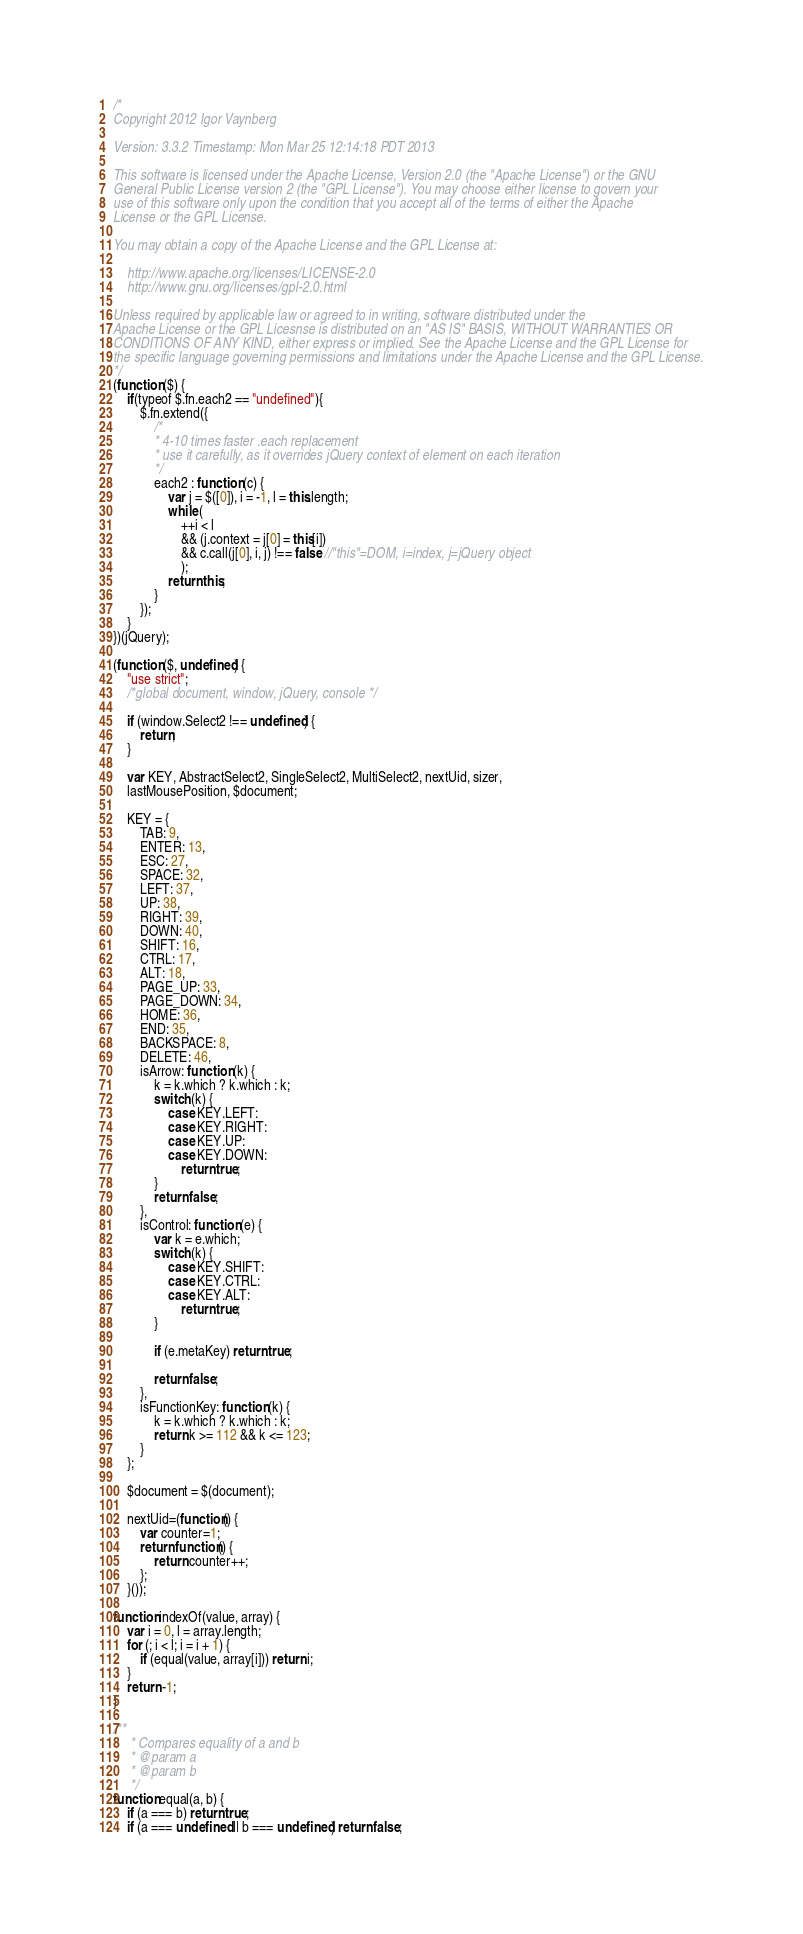Convert code to text. <code><loc_0><loc_0><loc_500><loc_500><_JavaScript_>/*
Copyright 2012 Igor Vaynberg

Version: 3.3.2 Timestamp: Mon Mar 25 12:14:18 PDT 2013

This software is licensed under the Apache License, Version 2.0 (the "Apache License") or the GNU
General Public License version 2 (the "GPL License"). You may choose either license to govern your
use of this software only upon the condition that you accept all of the terms of either the Apache
License or the GPL License.

You may obtain a copy of the Apache License and the GPL License at:

    http://www.apache.org/licenses/LICENSE-2.0
    http://www.gnu.org/licenses/gpl-2.0.html

Unless required by applicable law or agreed to in writing, software distributed under the
Apache License or the GPL Licesnse is distributed on an "AS IS" BASIS, WITHOUT WARRANTIES OR
CONDITIONS OF ANY KIND, either express or implied. See the Apache License and the GPL License for
the specific language governing permissions and limitations under the Apache License and the GPL License.
*/
(function ($) {
    if(typeof $.fn.each2 == "undefined"){
        $.fn.extend({
            /*
			* 4-10 times faster .each replacement
			* use it carefully, as it overrides jQuery context of element on each iteration
			*/
            each2 : function (c) {
                var j = $([0]), i = -1, l = this.length;
                while (
                    ++i < l
                    && (j.context = j[0] = this[i])
                    && c.call(j[0], i, j) !== false //"this"=DOM, i=index, j=jQuery object
                    );
                return this;
            }
        });
    }
})(jQuery);

(function ($, undefined) {
    "use strict";
    /*global document, window, jQuery, console */

    if (window.Select2 !== undefined) {
        return;
    }

    var KEY, AbstractSelect2, SingleSelect2, MultiSelect2, nextUid, sizer,
    lastMousePosition, $document;

    KEY = {
        TAB: 9,
        ENTER: 13,
        ESC: 27,
        SPACE: 32,
        LEFT: 37,
        UP: 38,
        RIGHT: 39,
        DOWN: 40,
        SHIFT: 16,
        CTRL: 17,
        ALT: 18,
        PAGE_UP: 33,
        PAGE_DOWN: 34,
        HOME: 36,
        END: 35,
        BACKSPACE: 8,
        DELETE: 46,
        isArrow: function (k) {
            k = k.which ? k.which : k;
            switch (k) {
                case KEY.LEFT:
                case KEY.RIGHT:
                case KEY.UP:
                case KEY.DOWN:
                    return true;
            }
            return false;
        },
        isControl: function (e) {
            var k = e.which;
            switch (k) {
                case KEY.SHIFT:
                case KEY.CTRL:
                case KEY.ALT:
                    return true;
            }

            if (e.metaKey) return true;

            return false;
        },
        isFunctionKey: function (k) {
            k = k.which ? k.which : k;
            return k >= 112 && k <= 123;
        }
    };

    $document = $(document);

    nextUid=(function() {
        var counter=1;
        return function() {
            return counter++;
        };    
    }());

function indexOf(value, array) {
    var i = 0, l = array.length;
    for (; i < l; i = i + 1) {
        if (equal(value, array[i])) return i;
    }
    return -1;
}

/**
     * Compares equality of a and b
     * @param a
     * @param b
     */
function equal(a, b) {
    if (a === b) return true;
    if (a === undefined || b === undefined) return false;</code> 